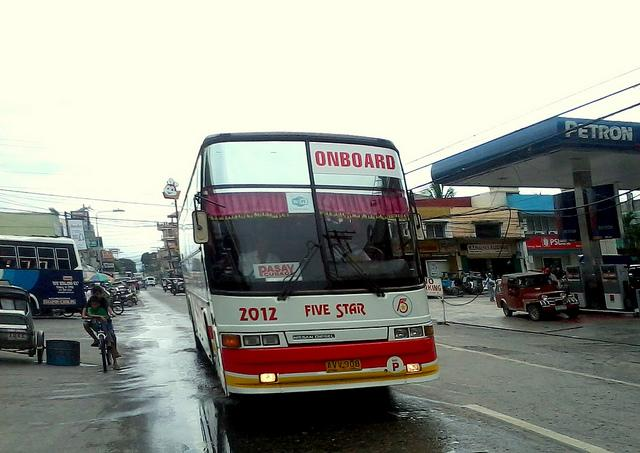Why is the red vehicle on the right stopped at the building? getting gas 